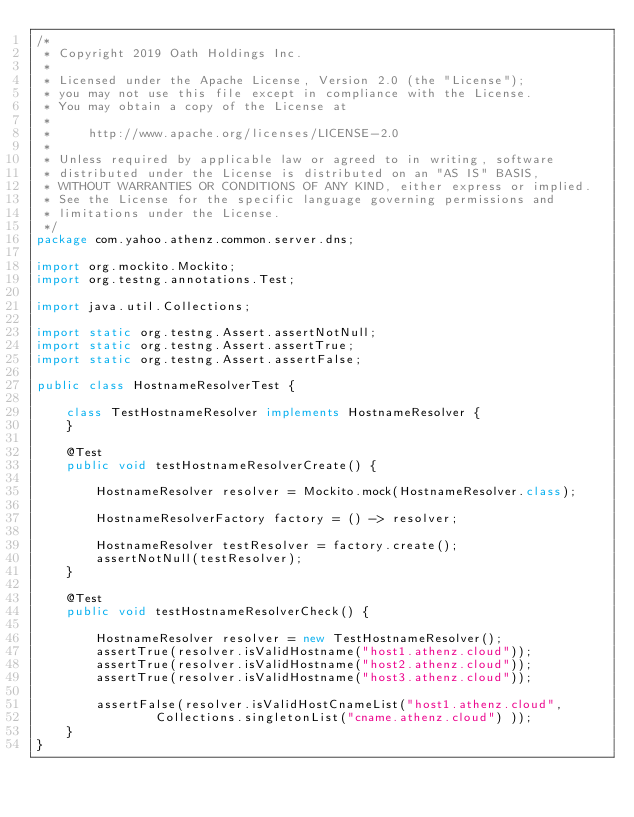<code> <loc_0><loc_0><loc_500><loc_500><_Java_>/*
 * Copyright 2019 Oath Holdings Inc.
 *
 * Licensed under the Apache License, Version 2.0 (the "License");
 * you may not use this file except in compliance with the License.
 * You may obtain a copy of the License at
 *
 *     http://www.apache.org/licenses/LICENSE-2.0
 *
 * Unless required by applicable law or agreed to in writing, software
 * distributed under the License is distributed on an "AS IS" BASIS,
 * WITHOUT WARRANTIES OR CONDITIONS OF ANY KIND, either express or implied.
 * See the License for the specific language governing permissions and
 * limitations under the License.
 */
package com.yahoo.athenz.common.server.dns;

import org.mockito.Mockito;
import org.testng.annotations.Test;

import java.util.Collections;

import static org.testng.Assert.assertNotNull;
import static org.testng.Assert.assertTrue;
import static org.testng.Assert.assertFalse;

public class HostnameResolverTest {

    class TestHostnameResolver implements HostnameResolver {
    }

    @Test
    public void testHostnameResolverCreate() {

        HostnameResolver resolver = Mockito.mock(HostnameResolver.class);

        HostnameResolverFactory factory = () -> resolver;

        HostnameResolver testResolver = factory.create();
        assertNotNull(testResolver);
    }

    @Test
    public void testHostnameResolverCheck() {

        HostnameResolver resolver = new TestHostnameResolver();
        assertTrue(resolver.isValidHostname("host1.athenz.cloud"));
        assertTrue(resolver.isValidHostname("host2.athenz.cloud"));
        assertTrue(resolver.isValidHostname("host3.athenz.cloud"));

        assertFalse(resolver.isValidHostCnameList("host1.athenz.cloud",
                Collections.singletonList("cname.athenz.cloud") ));
    }
}
</code> 